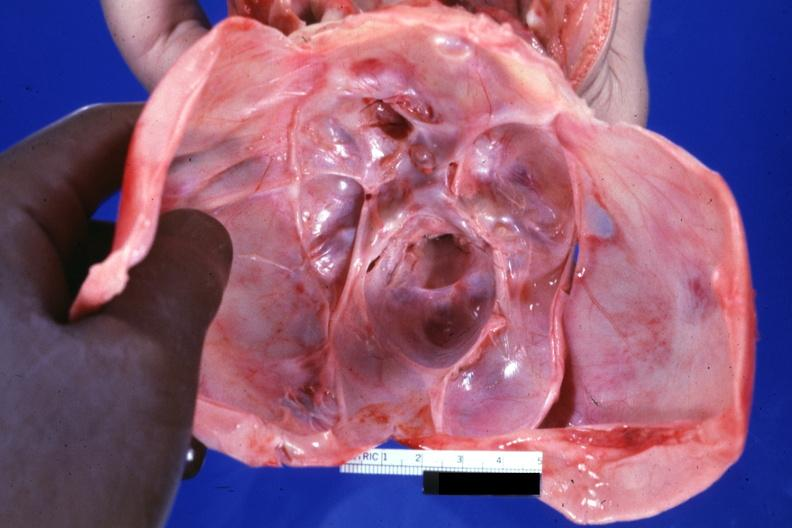s malformed base present?
Answer the question using a single word or phrase. Yes 